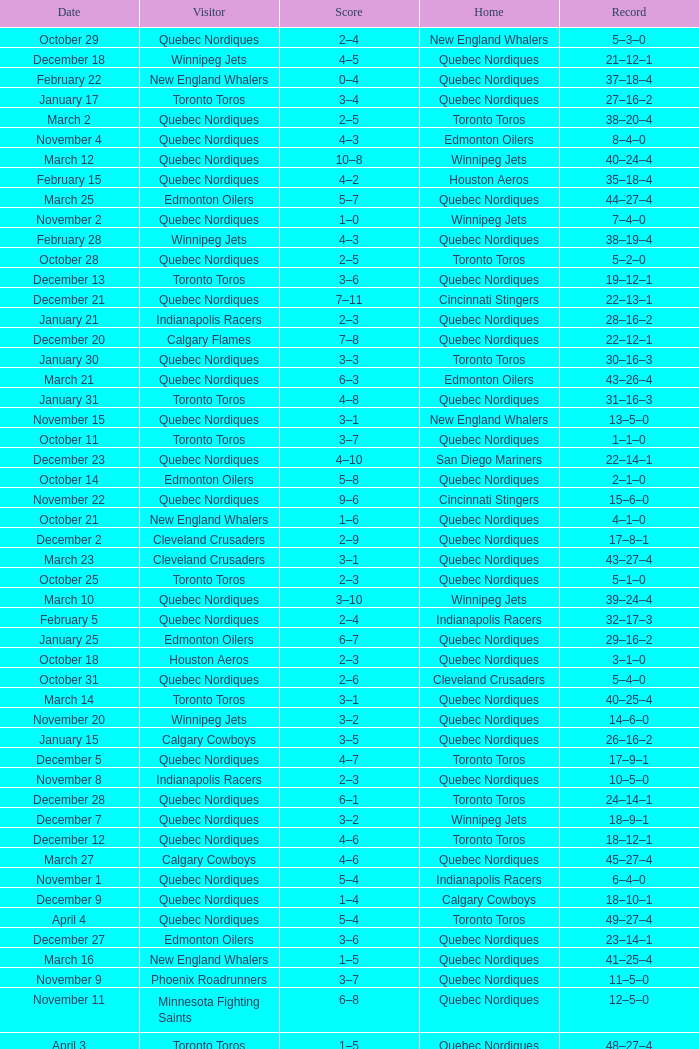What was the score of the game when the record was 39–21–4? 5–4. 